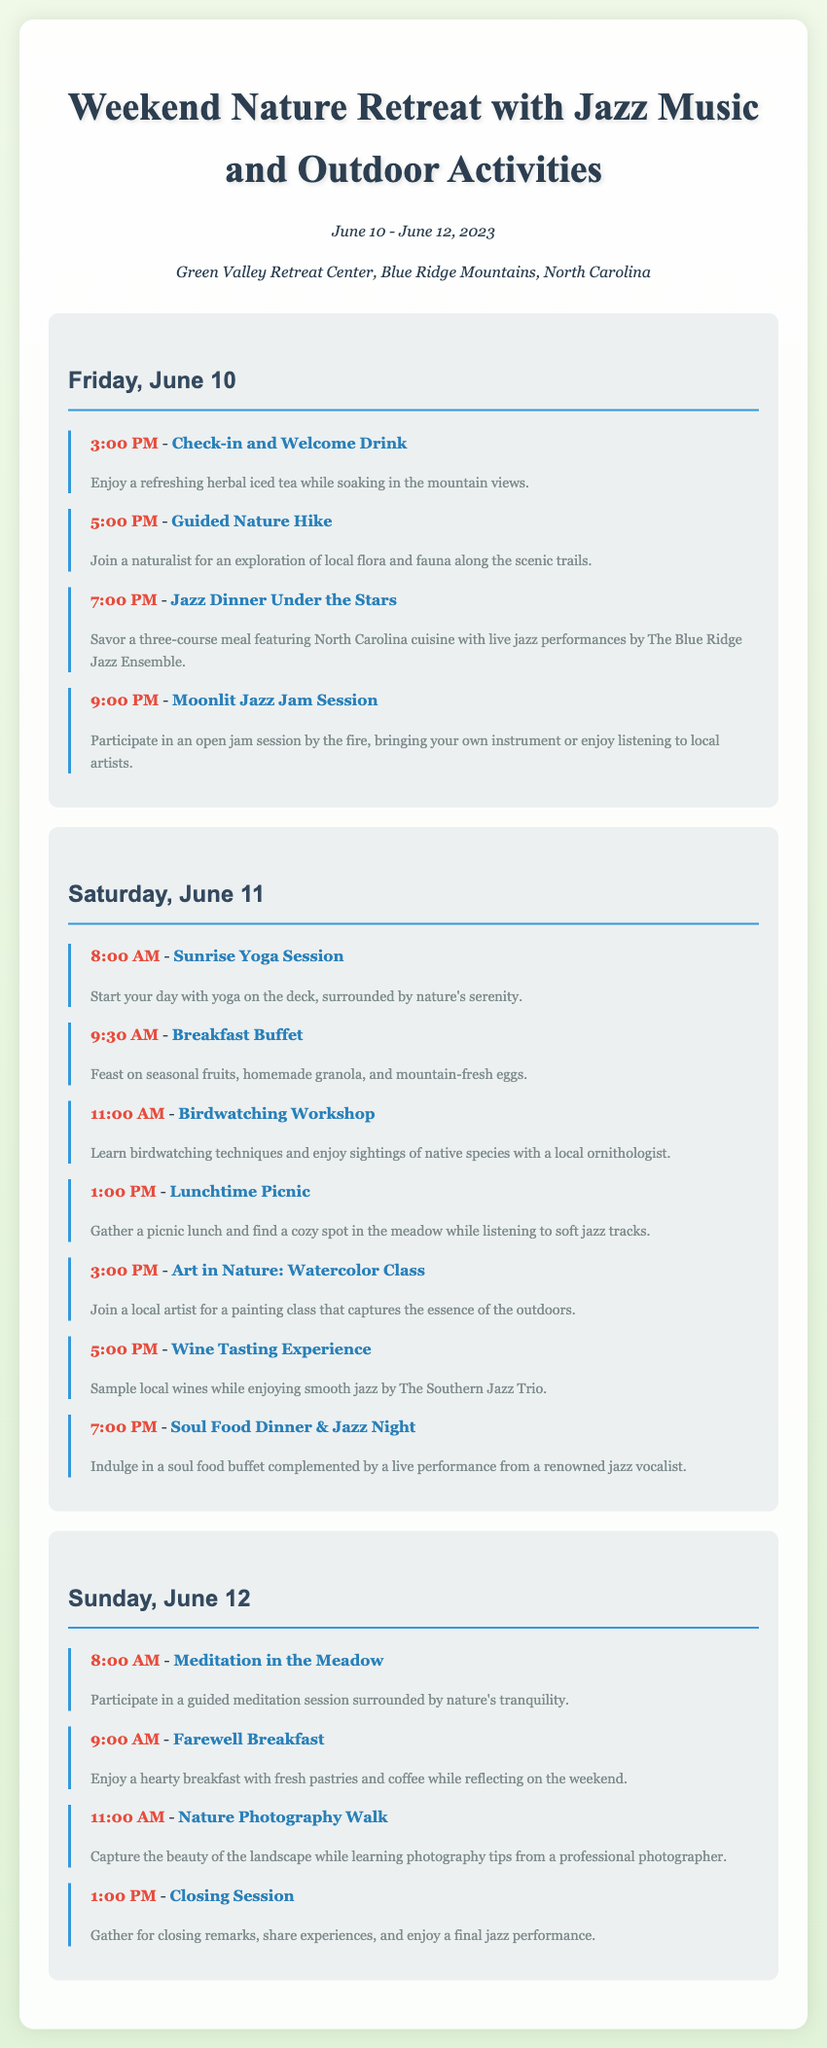What are the dates of the retreat? The document provides the specific dates for the retreat as June 10 - June 12, 2023.
Answer: June 10 - June 12, 2023 Where is the retreat located? The document states the location of the retreat as Green Valley Retreat Center, Blue Ridge Mountains, North Carolina.
Answer: Green Valley Retreat Center, Blue Ridge Mountains, North Carolina What time does the jazz dinner start on Friday? The schedule indicates that the Jazz Dinner Under the Stars starts at 7:00 PM on Friday.
Answer: 7:00 PM Which activity involves wine tasting? The document lists a Wine Tasting Experience scheduled for Saturday at 5:00 PM.
Answer: Wine Tasting Experience How many activities are planned for Saturday? The activities for Saturday are activities listed under that day's schedule, totaling seven distinct events.
Answer: 7 What is the name of the jazz ensemble performing on Friday? The document states that The Blue Ridge Jazz Ensemble is performing during the Jazz Dinner Under the Stars.
Answer: The Blue Ridge Jazz Ensemble What is held during the farewell breakfast? The farewell breakfast includes fresh pastries and coffee while reflecting on the weekend.
Answer: Fresh pastries and coffee What is the focus of the Nature Photography Walk? The scheduled activity focuses on capturing landscape beauty and learning photography tips from a professional photographer.
Answer: Capturing the beauty of the landscape What time does the Moonlit Jazz Jam Session start? The document specifies that the session begins at 9:00 PM on Friday.
Answer: 9:00 PM 